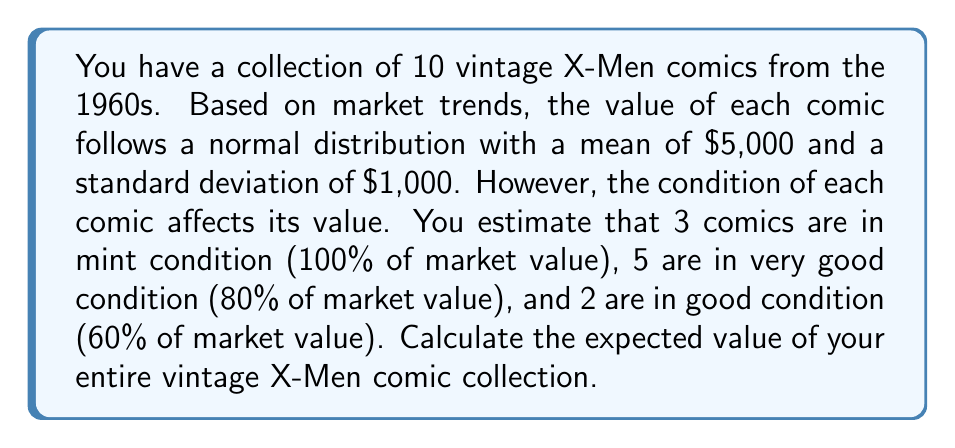Can you solve this math problem? Let's approach this problem step by step:

1) First, we need to calculate the expected value of a single comic in perfect condition:
   $E[X] = \mu = \$5,000$

2) Now, we need to adjust this value based on the condition of each comic:
   - Mint condition: $100\% \times \$5,000 = \$5,000$
   - Very good condition: $80\% \times \$5,000 = \$4,000$
   - Good condition: $60\% \times \$5,000 = \$3,000$

3) We can calculate the expected value of the collection by summing the expected values of each comic:
   $$E[\text{Collection}] = 3E[\text{Mint}] + 5E[\text{Very Good}] + 2E[\text{Good}]$$

4) Substituting the values:
   $$E[\text{Collection}] = 3(\$5,000) + 5(\$4,000) + 2(\$3,000)$$

5) Calculating:
   $$E[\text{Collection}] = \$15,000 + \$20,000 + \$6,000 = \$41,000$$

Therefore, the expected value of the entire vintage X-Men comic collection is $41,000.

Note: This calculation assumes independence between the comics' values and doesn't account for the standard deviation in the final result. In a more complex Bayesian analysis, we might consider the joint distribution of the comics' values and update our beliefs based on observed market data.
Answer: $41,000 